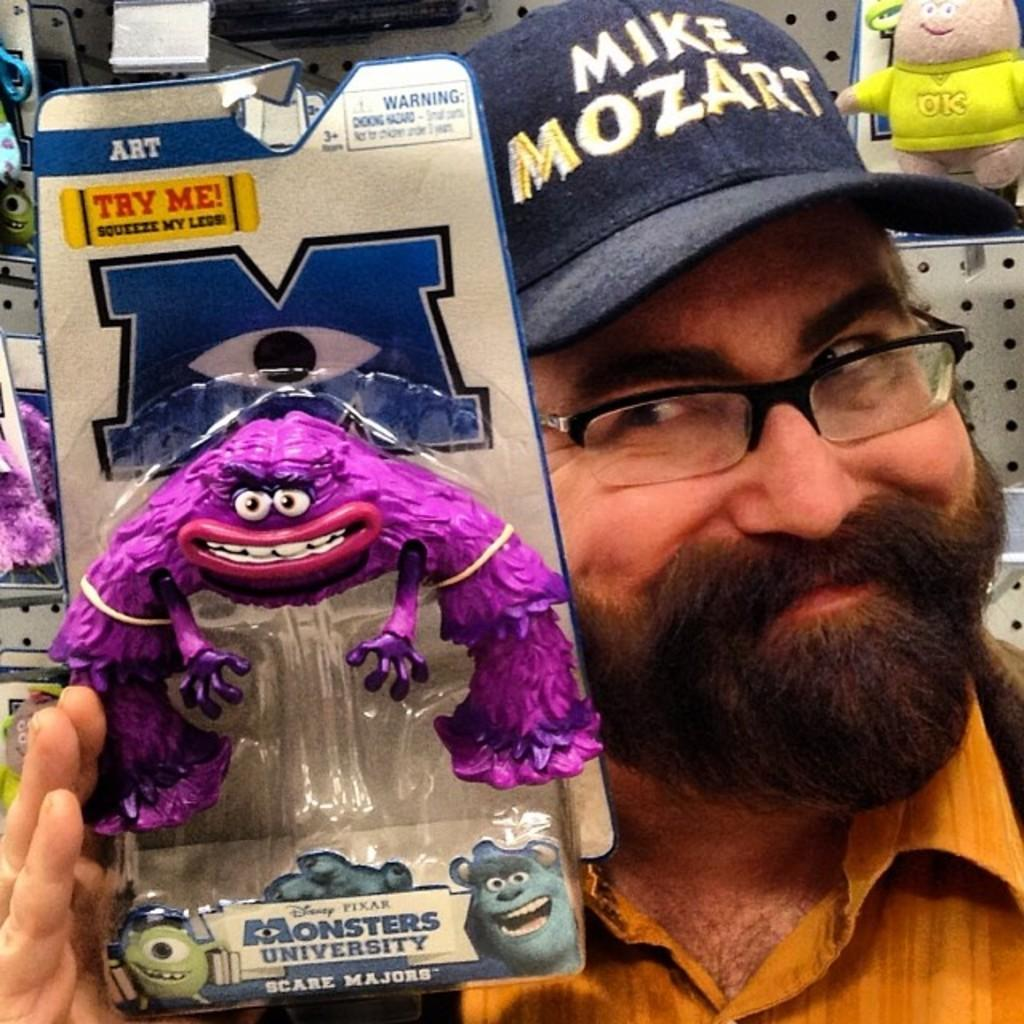What is the person in the image doing? The person is holding a packet and smiling. What color is the shirt the person is wearing? The person is wearing a brown shirt. What is inside the packet the person is holding? The packet contains a pink color doll. Can you describe the background of the image? There are dolls arranged on shelves in the background of the image. How many chickens are visible in the image? There are no chickens present in the image. What type of cable can be seen connecting the dolls in the image? There is no cable connecting the dolls in the image; they are arranged on shelves. 